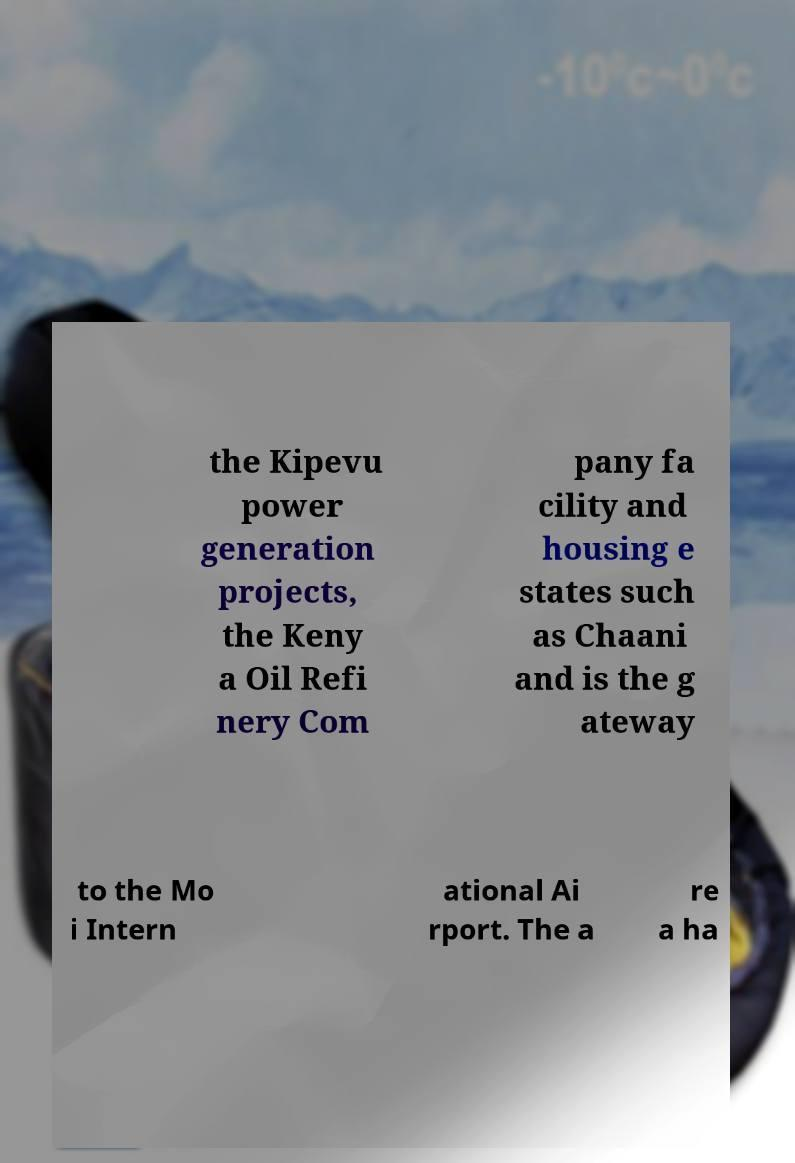Can you read and provide the text displayed in the image?This photo seems to have some interesting text. Can you extract and type it out for me? the Kipevu power generation projects, the Keny a Oil Refi nery Com pany fa cility and housing e states such as Chaani and is the g ateway to the Mo i Intern ational Ai rport. The a re a ha 